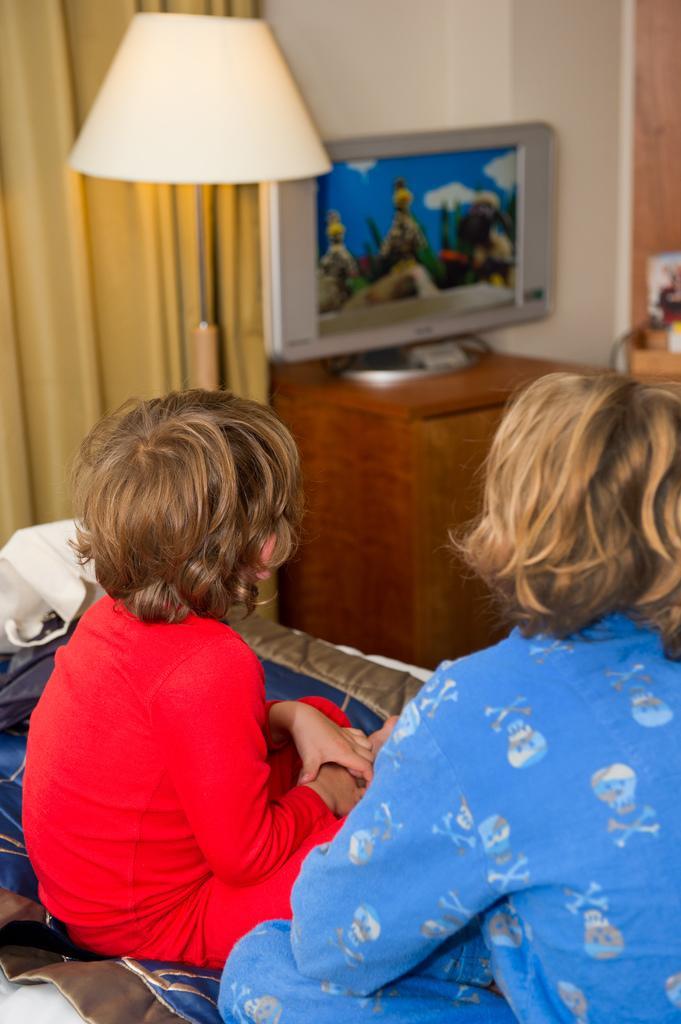How would you summarize this image in a sentence or two? In this image I see 2 children who are sitting, In the background I see a lamp, a TV on the table and the curtain. 